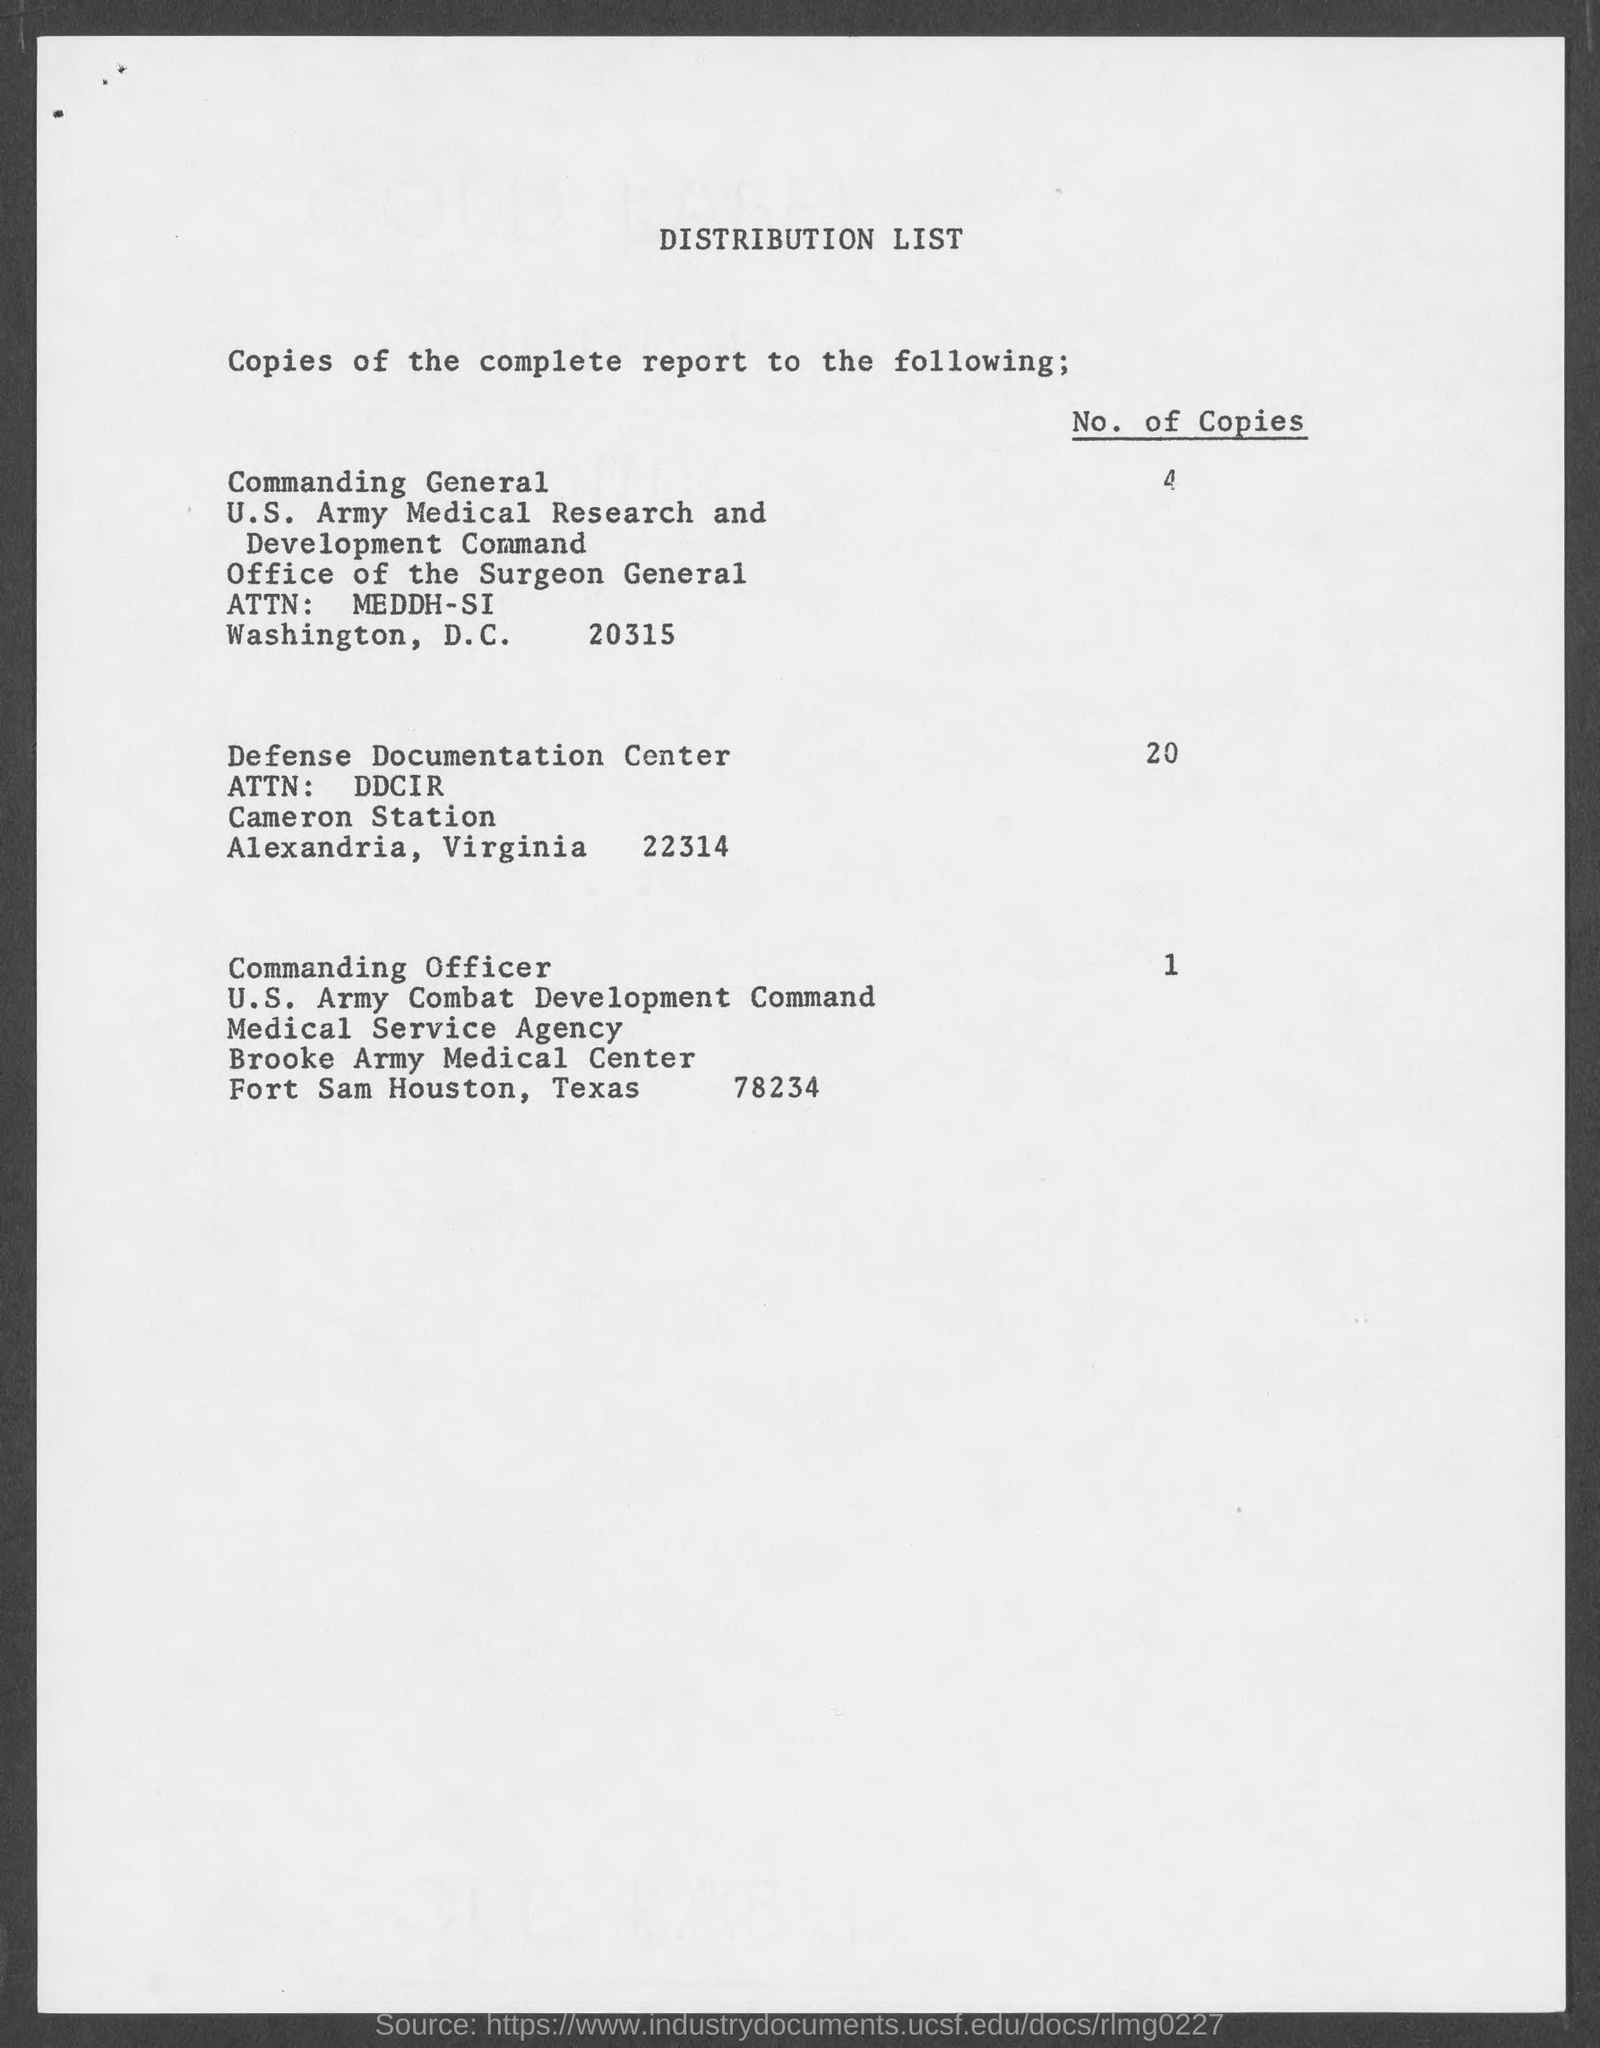What is the least number of copies sent to an organization, and which one is it? The least number of copies sent to an organization is 1, and it was sent to the U.S. Army Combat Development Command Medical Service Agency at Brooke Army Medical Center. 